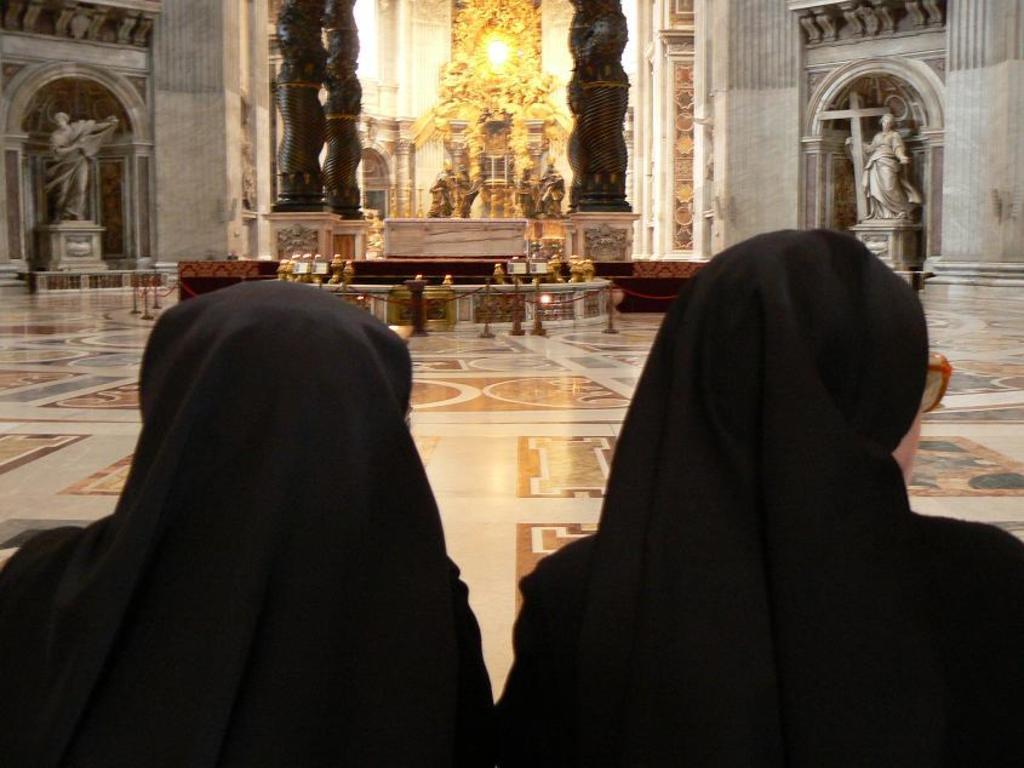Please provide a concise description of this image. In this picture we can see two women, in the background we can find few statues, metal rods and a light. 